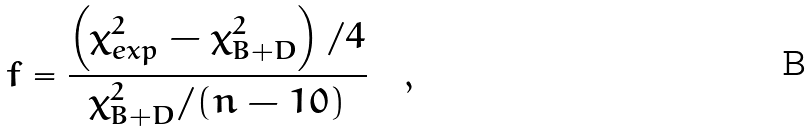Convert formula to latex. <formula><loc_0><loc_0><loc_500><loc_500>f = \frac { \left ( \chi ^ { 2 } _ { e x p } - \chi ^ { 2 } _ { B + D } \right ) / 4 } { \chi ^ { 2 } _ { B + D } / ( n - 1 0 ) } \quad ,</formula> 